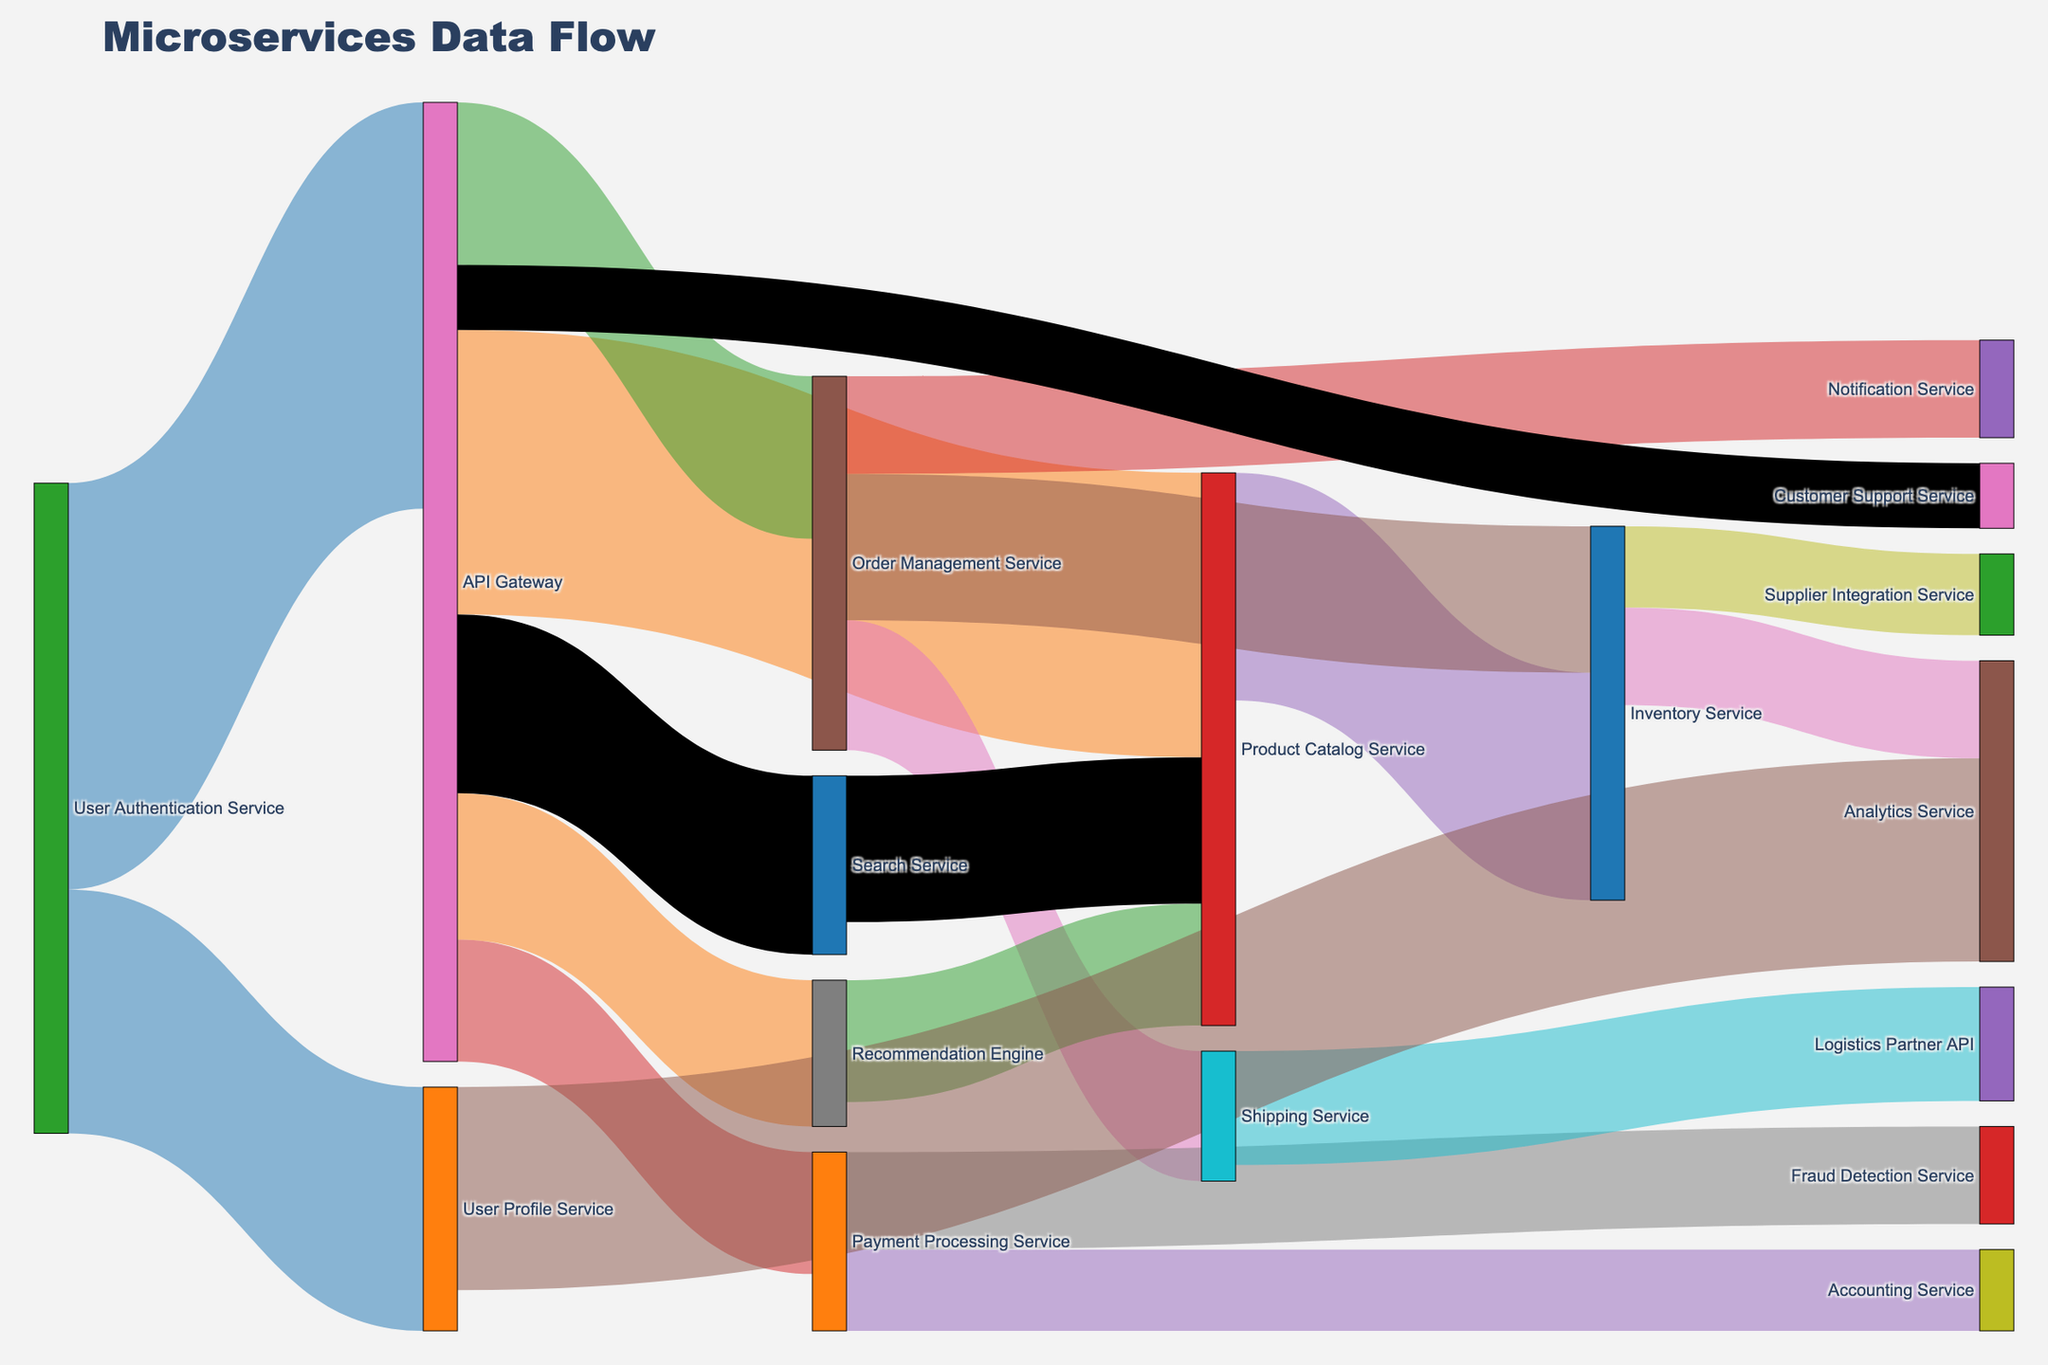What service has the highest traffic coming from the API Gateway? By observing the Sankey diagram, the flow from the API Gateway connecting to different services, the widest link indicates the highest traffic. The Product Catalog Service is connected by a wider link compared to the other services, indicating it has the highest traffic from the API Gateway.
Answer: Product Catalog Service How much traffic flows from the User Authentication Service to the API Gateway? The value of the link from the User Authentication Service to the API Gateway can be observed directly on the diagram. It shows a value of 5000.
Answer: 5000 What is the total traffic to the Inventory Service from all other services? In the diagram, the Inventory Service receives traffic from two sources: Product Catalog Service (2800) and Order Management Service (1800). Summing these gives 2800 + 1800.
Answer: 4600 Which service has the least traffic from the API Gateway? By examining the Sankey diagram, the smallest link from the API Gateway connects to the Customer Support Service, indicating the least traffic.
Answer: Customer Support Service What is the combined traffic flow from the Order Management Service to all other services? Order Management Service has three outgoing flows: Inventory Service (1800), Shipping Service (1600), and Notification Service (1200). Summing these values results in 1800 + 1600 + 1200.
Answer: 4600 How much traffic flows directly and indirectly to the Product Catalog Service? Direct traffic to the Product Catalog Service from the API Gateway is 3500. Indirect contributions come from the Recommendation Engine (1500). Summing these results in 3500 + 1500.
Answer: 5000 Compare the traffic from the API Gateway to the Payment Processing Service vs. the Recommendation Engine. Which is greater and by how much? The API Gateway sends 1500 to the Payment Processing Service and 1800 to the Recommendation Engine. The difference: 1800 - 1500.
Answer: Recommendation Engine by 300 Which services directly contribute to the analytics service traffic and by how much? Traffic to Analytics Service comes from User Profile Service (2500) and Inventory Service (1200). Summing these values: 2500 + 1200.
Answer: 3700 If the User Authentication Service failed, how much traffic would be lost to the system immediately? Consider the direct traffic from User Authentication Service: API Gateway (5000) and User Profile Service (3000). Summing these: 5000 + 3000.
Answer: 8000 